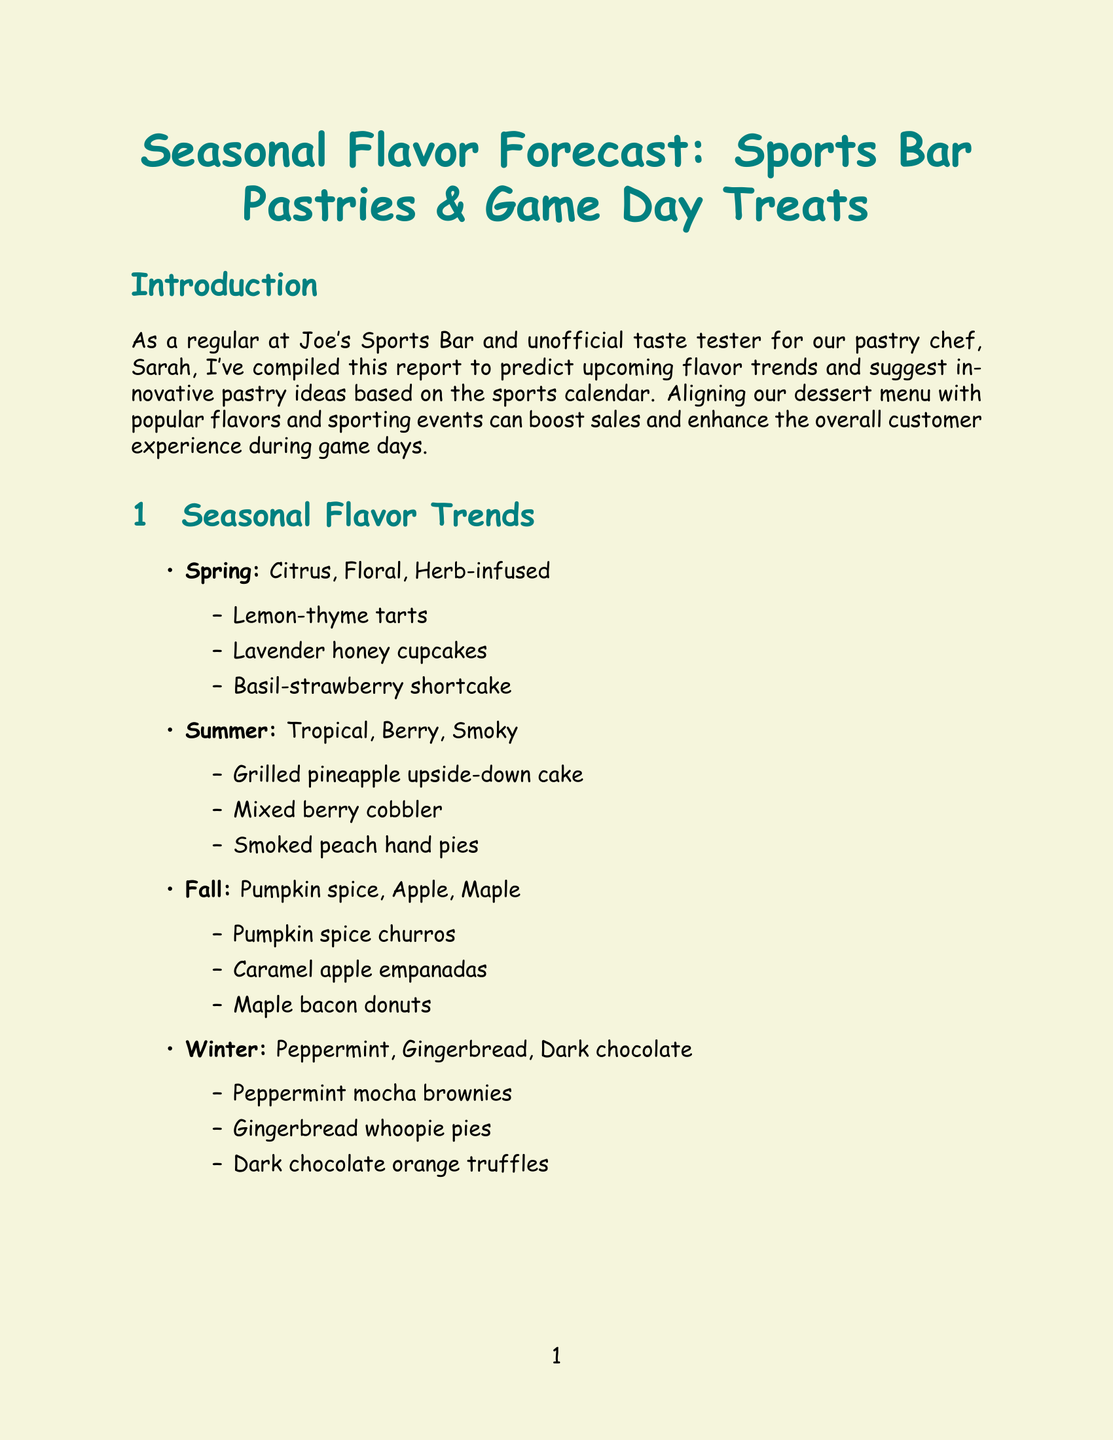What are the trending flavors for Spring? The document lists trending flavors for Spring under seasonal flavor trends, which are Citrus, Floral, and Herb-infused.
Answer: Citrus, Floral, Herb-infused What is a pastry idea for the Super Bowl? The document provides specific pastry ideas for the Super Bowl event in the sports calendar pastry innovations section. One idea is Football-shaped cream puffs.
Answer: Football-shaped cream puffs What is the conclusion's recommendation? The conclusion section of the document summarizes the findings and suggests discussing the ideas with Sarah and planning a tasting session.
Answer: Discussing ideas with Sarah Name one health-conscious option mentioned. Health-conscious options are listed in a section of the report. One of the options is Protein-packed Greek yogurt parfaits with house-made granola.
Answer: Protein-packed Greek yogurt parfaits with house-made granola Which pastry pairs with Bourbon peach iced tea? The document specifies pastry and beverage pairings in a section. The pastry paired with Bourbon peach iced tea is Smoked peach hand pies.
Answer: Smoked peach hand pies 